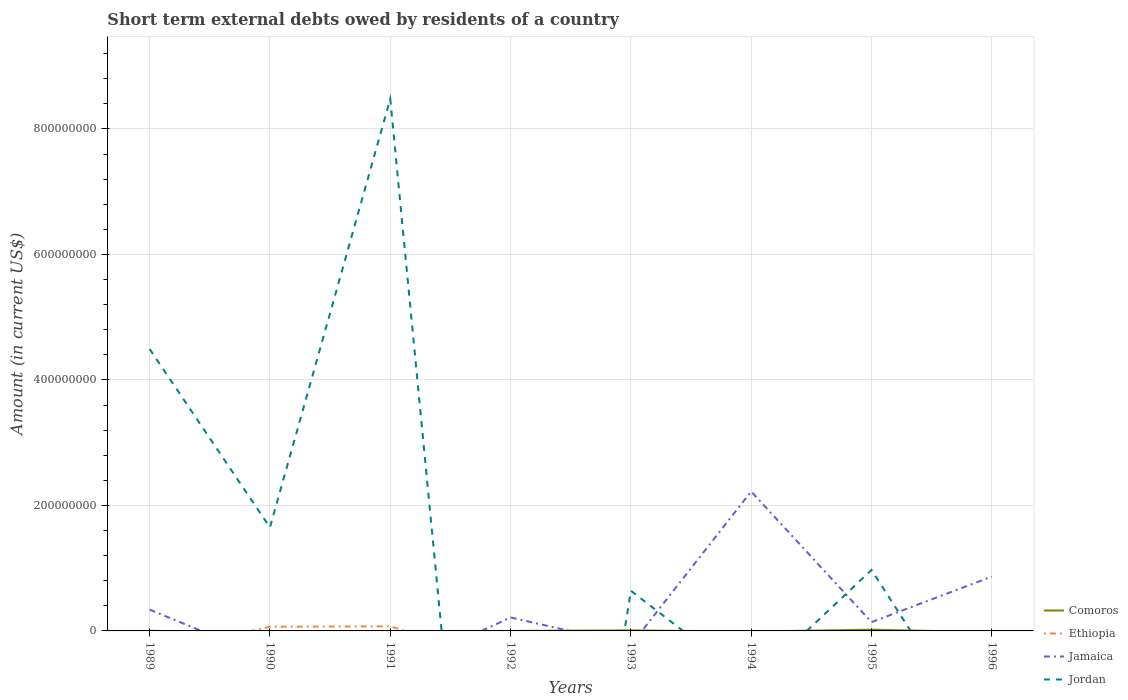Does the line corresponding to Comoros intersect with the line corresponding to Jordan?
Your answer should be very brief. Yes. Is the number of lines equal to the number of legend labels?
Offer a terse response. No. What is the total amount of short-term external debts owed by residents in Jamaica in the graph?
Keep it short and to the point. -5.26e+07. What is the difference between the highest and the second highest amount of short-term external debts owed by residents in Comoros?
Your answer should be compact. 2.00e+06. What is the difference between the highest and the lowest amount of short-term external debts owed by residents in Jamaica?
Keep it short and to the point. 2. How many years are there in the graph?
Make the answer very short. 8. Does the graph contain any zero values?
Your answer should be compact. Yes. Does the graph contain grids?
Give a very brief answer. Yes. Where does the legend appear in the graph?
Provide a short and direct response. Bottom right. How many legend labels are there?
Keep it short and to the point. 4. How are the legend labels stacked?
Make the answer very short. Vertical. What is the title of the graph?
Your answer should be very brief. Short term external debts owed by residents of a country. What is the label or title of the Y-axis?
Offer a terse response. Amount (in current US$). What is the Amount (in current US$) in Comoros in 1989?
Ensure brevity in your answer.  2.70e+05. What is the Amount (in current US$) of Jamaica in 1989?
Make the answer very short. 3.40e+07. What is the Amount (in current US$) in Jordan in 1989?
Offer a terse response. 4.49e+08. What is the Amount (in current US$) in Ethiopia in 1990?
Provide a succinct answer. 6.70e+06. What is the Amount (in current US$) in Jamaica in 1990?
Your answer should be compact. 0. What is the Amount (in current US$) of Jordan in 1990?
Provide a short and direct response. 1.65e+08. What is the Amount (in current US$) of Ethiopia in 1991?
Make the answer very short. 7.30e+06. What is the Amount (in current US$) in Jordan in 1991?
Make the answer very short. 8.48e+08. What is the Amount (in current US$) of Comoros in 1992?
Your answer should be compact. 0. What is the Amount (in current US$) in Jamaica in 1992?
Provide a succinct answer. 2.14e+07. What is the Amount (in current US$) in Comoros in 1993?
Your response must be concise. 8.80e+05. What is the Amount (in current US$) of Jamaica in 1993?
Give a very brief answer. 0. What is the Amount (in current US$) in Jordan in 1993?
Ensure brevity in your answer.  6.40e+07. What is the Amount (in current US$) of Comoros in 1994?
Provide a succinct answer. 0. What is the Amount (in current US$) in Ethiopia in 1994?
Your answer should be very brief. 2.30e+05. What is the Amount (in current US$) in Jamaica in 1994?
Provide a succinct answer. 2.22e+08. What is the Amount (in current US$) in Jordan in 1994?
Ensure brevity in your answer.  0. What is the Amount (in current US$) in Ethiopia in 1995?
Offer a very short reply. 0. What is the Amount (in current US$) in Jamaica in 1995?
Your response must be concise. 1.40e+07. What is the Amount (in current US$) in Jordan in 1995?
Make the answer very short. 9.72e+07. What is the Amount (in current US$) in Comoros in 1996?
Your response must be concise. 0. What is the Amount (in current US$) in Jamaica in 1996?
Offer a terse response. 8.66e+07. Across all years, what is the maximum Amount (in current US$) in Ethiopia?
Make the answer very short. 7.30e+06. Across all years, what is the maximum Amount (in current US$) in Jamaica?
Ensure brevity in your answer.  2.22e+08. Across all years, what is the maximum Amount (in current US$) in Jordan?
Your answer should be very brief. 8.48e+08. Across all years, what is the minimum Amount (in current US$) in Ethiopia?
Provide a succinct answer. 0. Across all years, what is the minimum Amount (in current US$) in Jordan?
Provide a short and direct response. 0. What is the total Amount (in current US$) in Comoros in the graph?
Make the answer very short. 3.15e+06. What is the total Amount (in current US$) in Ethiopia in the graph?
Give a very brief answer. 1.42e+07. What is the total Amount (in current US$) of Jamaica in the graph?
Provide a succinct answer. 3.78e+08. What is the total Amount (in current US$) of Jordan in the graph?
Ensure brevity in your answer.  1.62e+09. What is the difference between the Amount (in current US$) of Jordan in 1989 and that in 1990?
Your answer should be very brief. 2.84e+08. What is the difference between the Amount (in current US$) of Jordan in 1989 and that in 1991?
Your answer should be compact. -3.99e+08. What is the difference between the Amount (in current US$) in Jamaica in 1989 and that in 1992?
Provide a succinct answer. 1.26e+07. What is the difference between the Amount (in current US$) in Comoros in 1989 and that in 1993?
Provide a short and direct response. -6.10e+05. What is the difference between the Amount (in current US$) in Jordan in 1989 and that in 1993?
Offer a very short reply. 3.85e+08. What is the difference between the Amount (in current US$) in Jamaica in 1989 and that in 1994?
Offer a terse response. -1.88e+08. What is the difference between the Amount (in current US$) in Comoros in 1989 and that in 1995?
Keep it short and to the point. -1.73e+06. What is the difference between the Amount (in current US$) of Jamaica in 1989 and that in 1995?
Offer a terse response. 2.00e+07. What is the difference between the Amount (in current US$) in Jordan in 1989 and that in 1995?
Ensure brevity in your answer.  3.52e+08. What is the difference between the Amount (in current US$) of Jamaica in 1989 and that in 1996?
Provide a succinct answer. -5.26e+07. What is the difference between the Amount (in current US$) in Ethiopia in 1990 and that in 1991?
Offer a very short reply. -6.00e+05. What is the difference between the Amount (in current US$) of Jordan in 1990 and that in 1991?
Your answer should be very brief. -6.83e+08. What is the difference between the Amount (in current US$) of Jordan in 1990 and that in 1993?
Your answer should be compact. 1.01e+08. What is the difference between the Amount (in current US$) in Ethiopia in 1990 and that in 1994?
Offer a very short reply. 6.47e+06. What is the difference between the Amount (in current US$) in Jordan in 1990 and that in 1995?
Offer a terse response. 6.78e+07. What is the difference between the Amount (in current US$) of Jordan in 1991 and that in 1993?
Your answer should be compact. 7.84e+08. What is the difference between the Amount (in current US$) in Ethiopia in 1991 and that in 1994?
Your answer should be very brief. 7.07e+06. What is the difference between the Amount (in current US$) of Jordan in 1991 and that in 1995?
Your answer should be compact. 7.51e+08. What is the difference between the Amount (in current US$) of Jamaica in 1992 and that in 1994?
Make the answer very short. -2.01e+08. What is the difference between the Amount (in current US$) of Jamaica in 1992 and that in 1995?
Offer a terse response. 7.42e+06. What is the difference between the Amount (in current US$) in Jamaica in 1992 and that in 1996?
Your response must be concise. -6.52e+07. What is the difference between the Amount (in current US$) of Comoros in 1993 and that in 1995?
Give a very brief answer. -1.12e+06. What is the difference between the Amount (in current US$) in Jordan in 1993 and that in 1995?
Give a very brief answer. -3.32e+07. What is the difference between the Amount (in current US$) of Jamaica in 1994 and that in 1995?
Offer a very short reply. 2.08e+08. What is the difference between the Amount (in current US$) in Jamaica in 1994 and that in 1996?
Keep it short and to the point. 1.36e+08. What is the difference between the Amount (in current US$) in Jamaica in 1995 and that in 1996?
Ensure brevity in your answer.  -7.26e+07. What is the difference between the Amount (in current US$) in Comoros in 1989 and the Amount (in current US$) in Ethiopia in 1990?
Give a very brief answer. -6.43e+06. What is the difference between the Amount (in current US$) in Comoros in 1989 and the Amount (in current US$) in Jordan in 1990?
Provide a short and direct response. -1.65e+08. What is the difference between the Amount (in current US$) in Jamaica in 1989 and the Amount (in current US$) in Jordan in 1990?
Your response must be concise. -1.31e+08. What is the difference between the Amount (in current US$) of Comoros in 1989 and the Amount (in current US$) of Ethiopia in 1991?
Provide a succinct answer. -7.03e+06. What is the difference between the Amount (in current US$) in Comoros in 1989 and the Amount (in current US$) in Jordan in 1991?
Your answer should be compact. -8.48e+08. What is the difference between the Amount (in current US$) in Jamaica in 1989 and the Amount (in current US$) in Jordan in 1991?
Give a very brief answer. -8.14e+08. What is the difference between the Amount (in current US$) of Comoros in 1989 and the Amount (in current US$) of Jamaica in 1992?
Your answer should be compact. -2.12e+07. What is the difference between the Amount (in current US$) of Comoros in 1989 and the Amount (in current US$) of Jordan in 1993?
Ensure brevity in your answer.  -6.37e+07. What is the difference between the Amount (in current US$) of Jamaica in 1989 and the Amount (in current US$) of Jordan in 1993?
Ensure brevity in your answer.  -3.00e+07. What is the difference between the Amount (in current US$) in Comoros in 1989 and the Amount (in current US$) in Jamaica in 1994?
Provide a short and direct response. -2.22e+08. What is the difference between the Amount (in current US$) of Comoros in 1989 and the Amount (in current US$) of Jamaica in 1995?
Give a very brief answer. -1.38e+07. What is the difference between the Amount (in current US$) in Comoros in 1989 and the Amount (in current US$) in Jordan in 1995?
Keep it short and to the point. -9.69e+07. What is the difference between the Amount (in current US$) in Jamaica in 1989 and the Amount (in current US$) in Jordan in 1995?
Your answer should be very brief. -6.32e+07. What is the difference between the Amount (in current US$) in Comoros in 1989 and the Amount (in current US$) in Jamaica in 1996?
Your answer should be very brief. -8.63e+07. What is the difference between the Amount (in current US$) of Ethiopia in 1990 and the Amount (in current US$) of Jordan in 1991?
Your answer should be very brief. -8.41e+08. What is the difference between the Amount (in current US$) in Ethiopia in 1990 and the Amount (in current US$) in Jamaica in 1992?
Provide a short and direct response. -1.48e+07. What is the difference between the Amount (in current US$) of Ethiopia in 1990 and the Amount (in current US$) of Jordan in 1993?
Keep it short and to the point. -5.73e+07. What is the difference between the Amount (in current US$) in Ethiopia in 1990 and the Amount (in current US$) in Jamaica in 1994?
Offer a terse response. -2.16e+08. What is the difference between the Amount (in current US$) in Ethiopia in 1990 and the Amount (in current US$) in Jamaica in 1995?
Your answer should be compact. -7.33e+06. What is the difference between the Amount (in current US$) of Ethiopia in 1990 and the Amount (in current US$) of Jordan in 1995?
Provide a succinct answer. -9.05e+07. What is the difference between the Amount (in current US$) in Ethiopia in 1990 and the Amount (in current US$) in Jamaica in 1996?
Ensure brevity in your answer.  -7.99e+07. What is the difference between the Amount (in current US$) in Ethiopia in 1991 and the Amount (in current US$) in Jamaica in 1992?
Ensure brevity in your answer.  -1.42e+07. What is the difference between the Amount (in current US$) in Ethiopia in 1991 and the Amount (in current US$) in Jordan in 1993?
Your response must be concise. -5.67e+07. What is the difference between the Amount (in current US$) of Ethiopia in 1991 and the Amount (in current US$) of Jamaica in 1994?
Make the answer very short. -2.15e+08. What is the difference between the Amount (in current US$) of Ethiopia in 1991 and the Amount (in current US$) of Jamaica in 1995?
Your answer should be compact. -6.73e+06. What is the difference between the Amount (in current US$) of Ethiopia in 1991 and the Amount (in current US$) of Jordan in 1995?
Keep it short and to the point. -8.99e+07. What is the difference between the Amount (in current US$) in Ethiopia in 1991 and the Amount (in current US$) in Jamaica in 1996?
Give a very brief answer. -7.93e+07. What is the difference between the Amount (in current US$) in Jamaica in 1992 and the Amount (in current US$) in Jordan in 1993?
Offer a very short reply. -4.26e+07. What is the difference between the Amount (in current US$) in Jamaica in 1992 and the Amount (in current US$) in Jordan in 1995?
Your response must be concise. -7.58e+07. What is the difference between the Amount (in current US$) in Comoros in 1993 and the Amount (in current US$) in Ethiopia in 1994?
Provide a short and direct response. 6.50e+05. What is the difference between the Amount (in current US$) in Comoros in 1993 and the Amount (in current US$) in Jamaica in 1994?
Ensure brevity in your answer.  -2.21e+08. What is the difference between the Amount (in current US$) in Comoros in 1993 and the Amount (in current US$) in Jamaica in 1995?
Your response must be concise. -1.32e+07. What is the difference between the Amount (in current US$) in Comoros in 1993 and the Amount (in current US$) in Jordan in 1995?
Give a very brief answer. -9.63e+07. What is the difference between the Amount (in current US$) in Comoros in 1993 and the Amount (in current US$) in Jamaica in 1996?
Provide a succinct answer. -8.57e+07. What is the difference between the Amount (in current US$) of Ethiopia in 1994 and the Amount (in current US$) of Jamaica in 1995?
Provide a short and direct response. -1.38e+07. What is the difference between the Amount (in current US$) of Ethiopia in 1994 and the Amount (in current US$) of Jordan in 1995?
Provide a short and direct response. -9.70e+07. What is the difference between the Amount (in current US$) of Jamaica in 1994 and the Amount (in current US$) of Jordan in 1995?
Your answer should be compact. 1.25e+08. What is the difference between the Amount (in current US$) of Ethiopia in 1994 and the Amount (in current US$) of Jamaica in 1996?
Your answer should be compact. -8.64e+07. What is the difference between the Amount (in current US$) of Comoros in 1995 and the Amount (in current US$) of Jamaica in 1996?
Your answer should be very brief. -8.46e+07. What is the average Amount (in current US$) in Comoros per year?
Keep it short and to the point. 3.94e+05. What is the average Amount (in current US$) of Ethiopia per year?
Offer a very short reply. 1.78e+06. What is the average Amount (in current US$) of Jamaica per year?
Offer a very short reply. 4.73e+07. What is the average Amount (in current US$) in Jordan per year?
Offer a very short reply. 2.03e+08. In the year 1989, what is the difference between the Amount (in current US$) of Comoros and Amount (in current US$) of Jamaica?
Keep it short and to the point. -3.37e+07. In the year 1989, what is the difference between the Amount (in current US$) of Comoros and Amount (in current US$) of Jordan?
Keep it short and to the point. -4.49e+08. In the year 1989, what is the difference between the Amount (in current US$) of Jamaica and Amount (in current US$) of Jordan?
Ensure brevity in your answer.  -4.15e+08. In the year 1990, what is the difference between the Amount (in current US$) in Ethiopia and Amount (in current US$) in Jordan?
Keep it short and to the point. -1.58e+08. In the year 1991, what is the difference between the Amount (in current US$) of Ethiopia and Amount (in current US$) of Jordan?
Keep it short and to the point. -8.41e+08. In the year 1993, what is the difference between the Amount (in current US$) in Comoros and Amount (in current US$) in Jordan?
Your answer should be very brief. -6.31e+07. In the year 1994, what is the difference between the Amount (in current US$) in Ethiopia and Amount (in current US$) in Jamaica?
Your answer should be compact. -2.22e+08. In the year 1995, what is the difference between the Amount (in current US$) in Comoros and Amount (in current US$) in Jamaica?
Offer a very short reply. -1.20e+07. In the year 1995, what is the difference between the Amount (in current US$) of Comoros and Amount (in current US$) of Jordan?
Offer a terse response. -9.52e+07. In the year 1995, what is the difference between the Amount (in current US$) in Jamaica and Amount (in current US$) in Jordan?
Offer a terse response. -8.32e+07. What is the ratio of the Amount (in current US$) of Jordan in 1989 to that in 1990?
Ensure brevity in your answer.  2.72. What is the ratio of the Amount (in current US$) in Jordan in 1989 to that in 1991?
Provide a succinct answer. 0.53. What is the ratio of the Amount (in current US$) in Jamaica in 1989 to that in 1992?
Keep it short and to the point. 1.59. What is the ratio of the Amount (in current US$) in Comoros in 1989 to that in 1993?
Provide a succinct answer. 0.31. What is the ratio of the Amount (in current US$) in Jordan in 1989 to that in 1993?
Keep it short and to the point. 7.02. What is the ratio of the Amount (in current US$) of Jamaica in 1989 to that in 1994?
Offer a terse response. 0.15. What is the ratio of the Amount (in current US$) of Comoros in 1989 to that in 1995?
Make the answer very short. 0.14. What is the ratio of the Amount (in current US$) of Jamaica in 1989 to that in 1995?
Provide a succinct answer. 2.42. What is the ratio of the Amount (in current US$) in Jordan in 1989 to that in 1995?
Offer a very short reply. 4.62. What is the ratio of the Amount (in current US$) of Jamaica in 1989 to that in 1996?
Provide a short and direct response. 0.39. What is the ratio of the Amount (in current US$) of Ethiopia in 1990 to that in 1991?
Ensure brevity in your answer.  0.92. What is the ratio of the Amount (in current US$) of Jordan in 1990 to that in 1991?
Your answer should be compact. 0.19. What is the ratio of the Amount (in current US$) in Jordan in 1990 to that in 1993?
Offer a very short reply. 2.58. What is the ratio of the Amount (in current US$) of Ethiopia in 1990 to that in 1994?
Offer a very short reply. 29.13. What is the ratio of the Amount (in current US$) in Jordan in 1990 to that in 1995?
Your answer should be compact. 1.7. What is the ratio of the Amount (in current US$) of Jordan in 1991 to that in 1993?
Your answer should be very brief. 13.25. What is the ratio of the Amount (in current US$) in Ethiopia in 1991 to that in 1994?
Ensure brevity in your answer.  31.74. What is the ratio of the Amount (in current US$) of Jordan in 1991 to that in 1995?
Give a very brief answer. 8.72. What is the ratio of the Amount (in current US$) in Jamaica in 1992 to that in 1994?
Your answer should be compact. 0.1. What is the ratio of the Amount (in current US$) of Jamaica in 1992 to that in 1995?
Your response must be concise. 1.53. What is the ratio of the Amount (in current US$) of Jamaica in 1992 to that in 1996?
Make the answer very short. 0.25. What is the ratio of the Amount (in current US$) of Comoros in 1993 to that in 1995?
Provide a succinct answer. 0.44. What is the ratio of the Amount (in current US$) in Jordan in 1993 to that in 1995?
Your response must be concise. 0.66. What is the ratio of the Amount (in current US$) in Jamaica in 1994 to that in 1995?
Provide a succinct answer. 15.84. What is the ratio of the Amount (in current US$) of Jamaica in 1994 to that in 1996?
Your response must be concise. 2.57. What is the ratio of the Amount (in current US$) in Jamaica in 1995 to that in 1996?
Provide a short and direct response. 0.16. What is the difference between the highest and the second highest Amount (in current US$) of Comoros?
Provide a succinct answer. 1.12e+06. What is the difference between the highest and the second highest Amount (in current US$) in Ethiopia?
Your answer should be compact. 6.00e+05. What is the difference between the highest and the second highest Amount (in current US$) in Jamaica?
Offer a terse response. 1.36e+08. What is the difference between the highest and the second highest Amount (in current US$) of Jordan?
Provide a succinct answer. 3.99e+08. What is the difference between the highest and the lowest Amount (in current US$) of Ethiopia?
Your answer should be compact. 7.30e+06. What is the difference between the highest and the lowest Amount (in current US$) in Jamaica?
Ensure brevity in your answer.  2.22e+08. What is the difference between the highest and the lowest Amount (in current US$) in Jordan?
Your answer should be compact. 8.48e+08. 